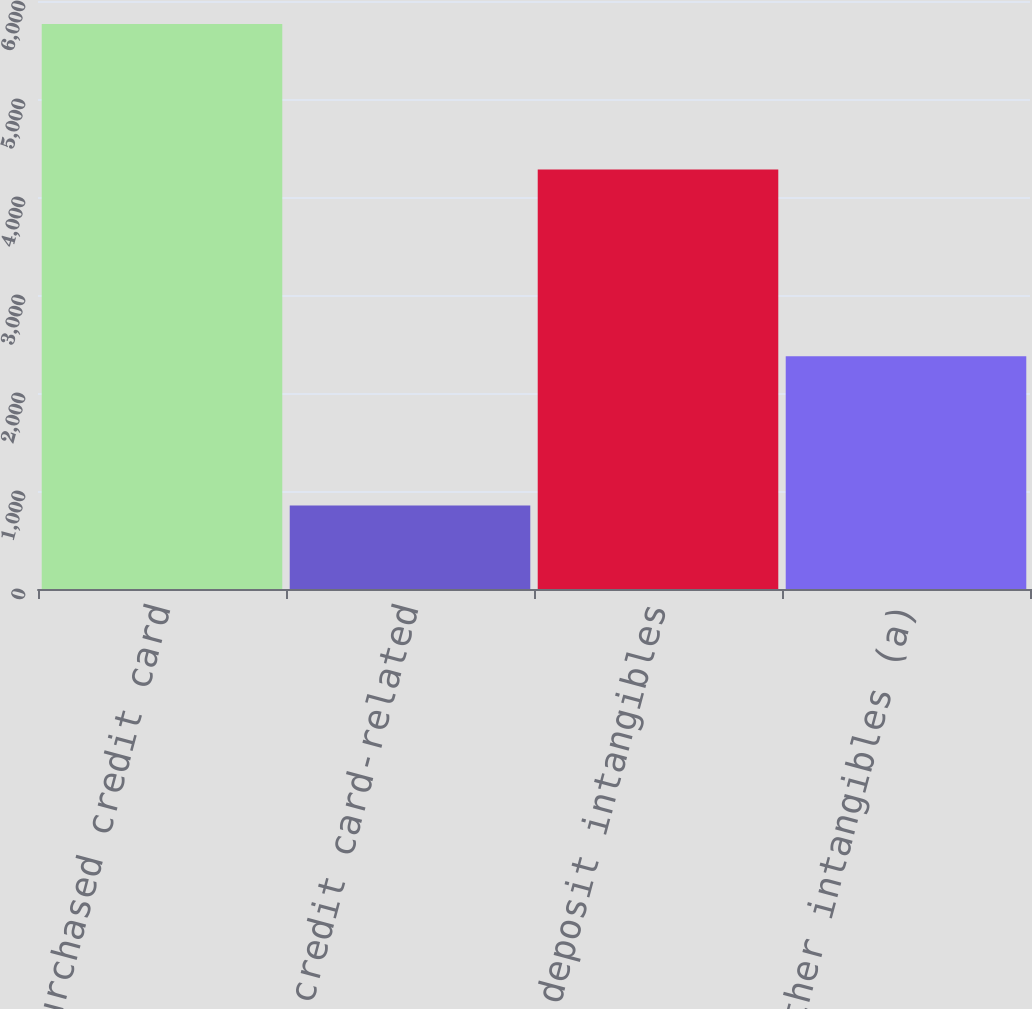Convert chart. <chart><loc_0><loc_0><loc_500><loc_500><bar_chart><fcel>Purchased credit card<fcel>Other credit card-related<fcel>Core deposit intangibles<fcel>Other intangibles (a)<nl><fcel>5765<fcel>852<fcel>4280<fcel>2376<nl></chart> 